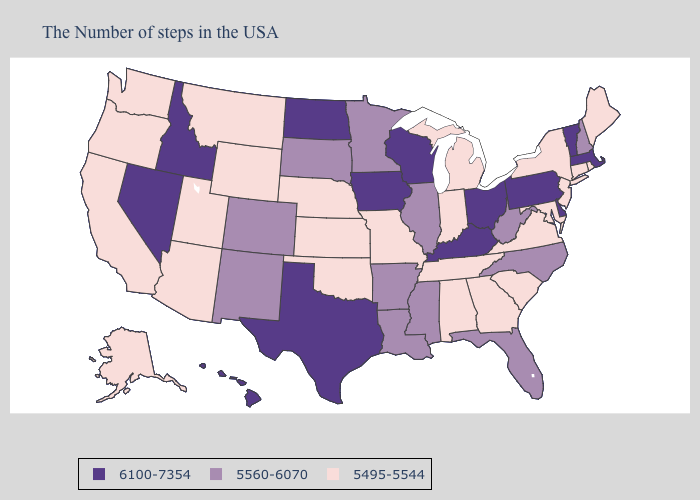Name the states that have a value in the range 5560-6070?
Keep it brief. New Hampshire, North Carolina, West Virginia, Florida, Illinois, Mississippi, Louisiana, Arkansas, Minnesota, South Dakota, Colorado, New Mexico. What is the highest value in the South ?
Quick response, please. 6100-7354. What is the value of Kansas?
Quick response, please. 5495-5544. Which states have the lowest value in the USA?
Quick response, please. Maine, Rhode Island, Connecticut, New York, New Jersey, Maryland, Virginia, South Carolina, Georgia, Michigan, Indiana, Alabama, Tennessee, Missouri, Kansas, Nebraska, Oklahoma, Wyoming, Utah, Montana, Arizona, California, Washington, Oregon, Alaska. Does Illinois have a lower value than Washington?
Quick response, please. No. Name the states that have a value in the range 6100-7354?
Concise answer only. Massachusetts, Vermont, Delaware, Pennsylvania, Ohio, Kentucky, Wisconsin, Iowa, Texas, North Dakota, Idaho, Nevada, Hawaii. What is the lowest value in states that border Pennsylvania?
Keep it brief. 5495-5544. What is the value of Alaska?
Quick response, please. 5495-5544. What is the value of Georgia?
Concise answer only. 5495-5544. Which states have the lowest value in the USA?
Keep it brief. Maine, Rhode Island, Connecticut, New York, New Jersey, Maryland, Virginia, South Carolina, Georgia, Michigan, Indiana, Alabama, Tennessee, Missouri, Kansas, Nebraska, Oklahoma, Wyoming, Utah, Montana, Arizona, California, Washington, Oregon, Alaska. Name the states that have a value in the range 5560-6070?
Be succinct. New Hampshire, North Carolina, West Virginia, Florida, Illinois, Mississippi, Louisiana, Arkansas, Minnesota, South Dakota, Colorado, New Mexico. Does Virginia have a lower value than Nebraska?
Short answer required. No. Is the legend a continuous bar?
Write a very short answer. No. Which states have the lowest value in the USA?
Keep it brief. Maine, Rhode Island, Connecticut, New York, New Jersey, Maryland, Virginia, South Carolina, Georgia, Michigan, Indiana, Alabama, Tennessee, Missouri, Kansas, Nebraska, Oklahoma, Wyoming, Utah, Montana, Arizona, California, Washington, Oregon, Alaska. What is the highest value in the USA?
Give a very brief answer. 6100-7354. 